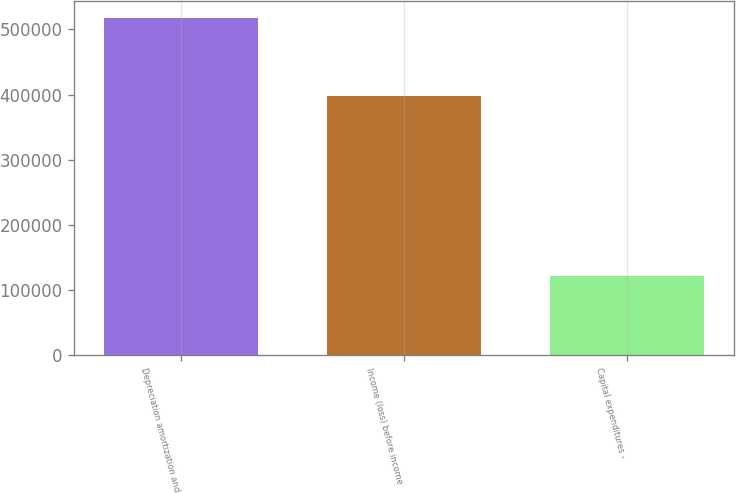Convert chart. <chart><loc_0><loc_0><loc_500><loc_500><bar_chart><fcel>Depreciation amortization and<fcel>Income (loss) before income<fcel>Capital expenditures -<nl><fcel>517857<fcel>397060<fcel>120537<nl></chart> 